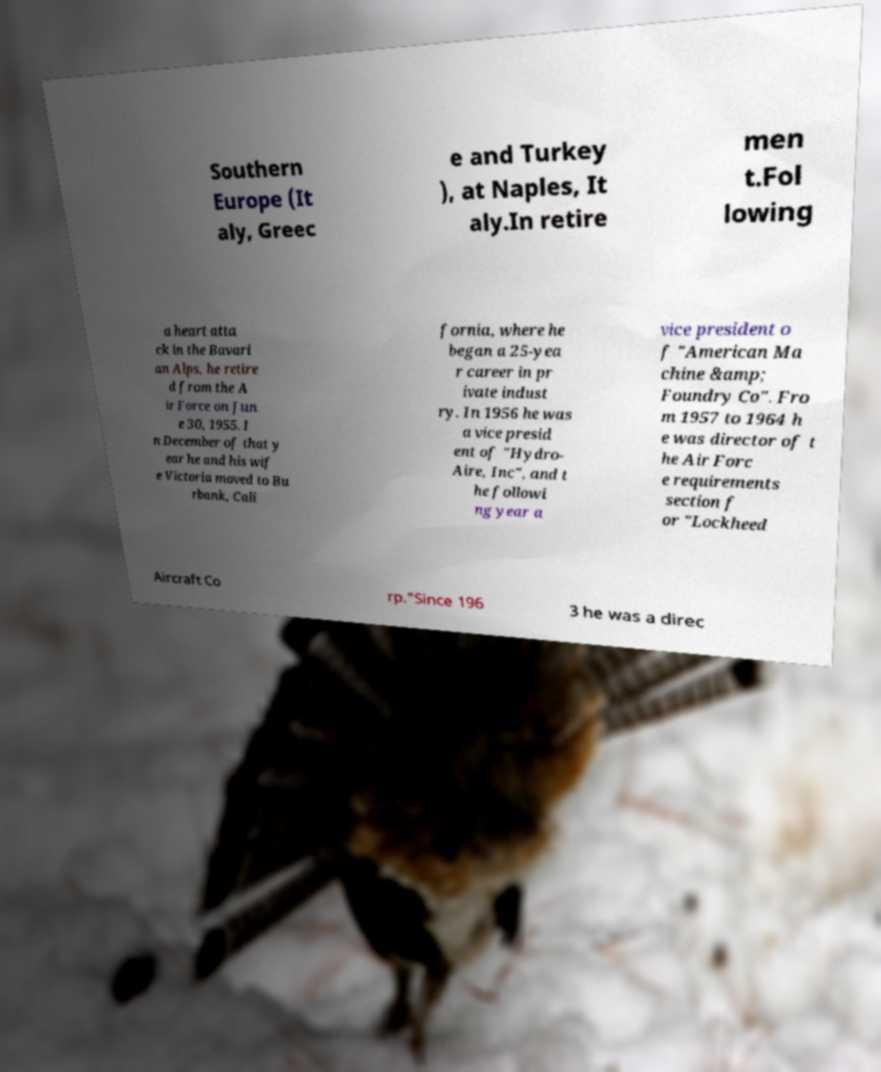What messages or text are displayed in this image? I need them in a readable, typed format. Southern Europe (It aly, Greec e and Turkey ), at Naples, It aly.In retire men t.Fol lowing a heart atta ck in the Bavari an Alps, he retire d from the A ir Force on Jun e 30, 1955. I n December of that y ear he and his wif e Victoria moved to Bu rbank, Cali fornia, where he began a 25-yea r career in pr ivate indust ry. In 1956 he was a vice presid ent of "Hydro- Aire, Inc", and t he followi ng year a vice president o f "American Ma chine &amp; Foundry Co". Fro m 1957 to 1964 h e was director of t he Air Forc e requirements section f or "Lockheed Aircraft Co rp."Since 196 3 he was a direc 